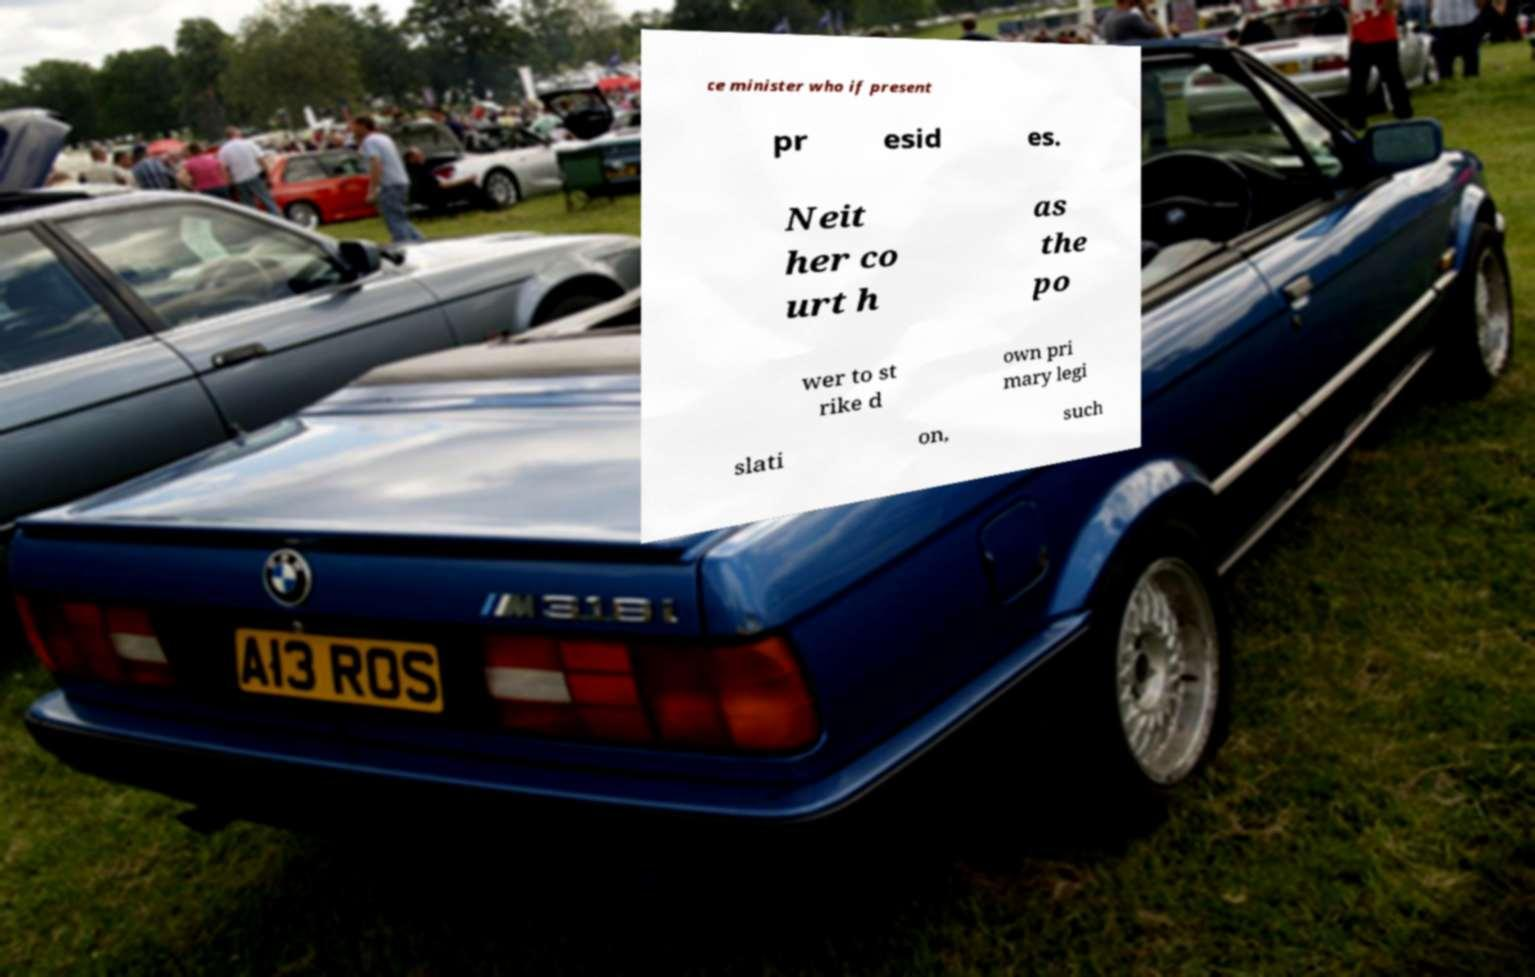Please identify and transcribe the text found in this image. ce minister who if present pr esid es. Neit her co urt h as the po wer to st rike d own pri mary legi slati on, such 